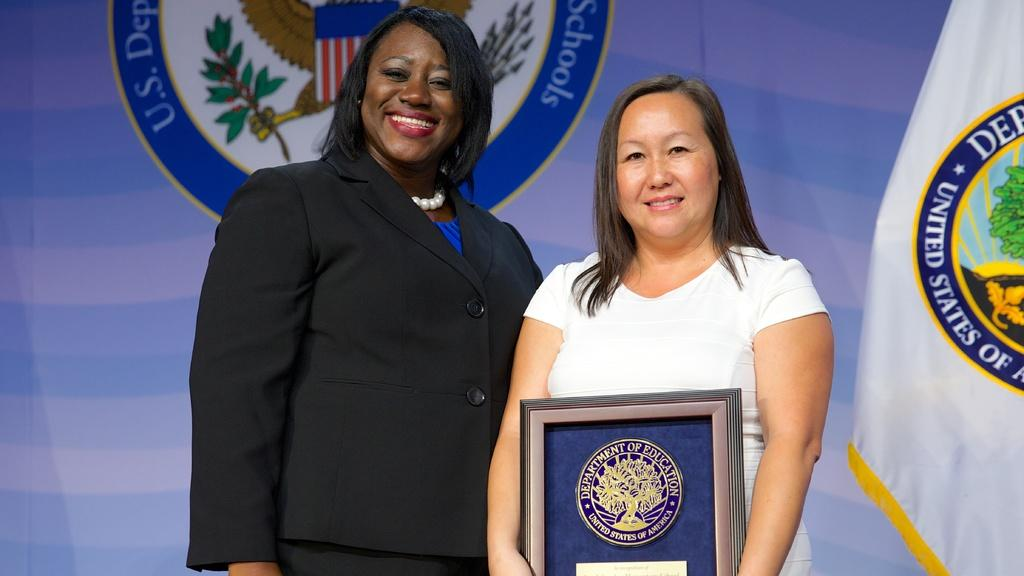Provide a one-sentence caption for the provided image. A woman is presenting an award to another woman with the United States Presidential Seal in the background. 